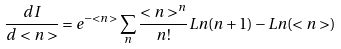Convert formula to latex. <formula><loc_0><loc_0><loc_500><loc_500>\frac { d I } { d < n > } = e ^ { - < n > } \sum _ { n } \frac { < n > ^ { n } } { n ! } L n ( n + 1 ) - L n ( < n > )</formula> 